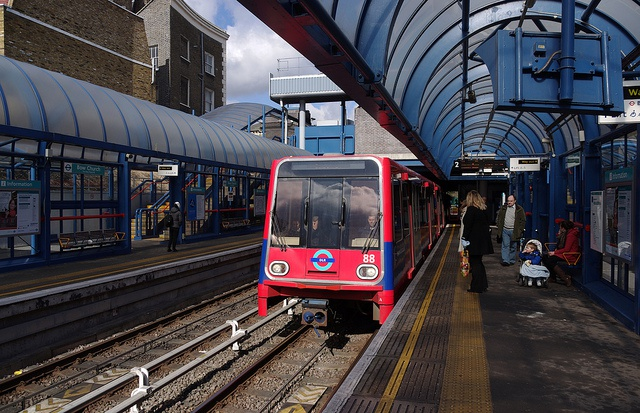Describe the objects in this image and their specific colors. I can see train in salmon, black, gray, red, and darkgray tones, people in salmon, black, gray, and maroon tones, people in salmon, black, blue, and gray tones, people in salmon, black, maroon, and brown tones, and bench in salmon, black, gray, and maroon tones in this image. 